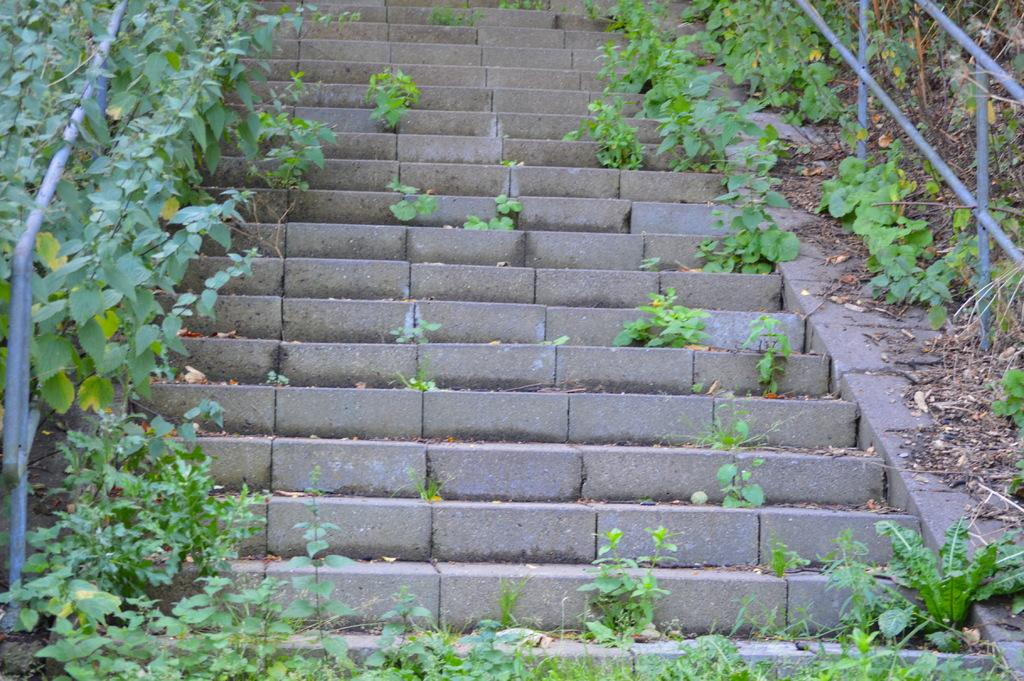What type of architectural feature can be seen in the image? There are steps in the image. What is the purpose of the fencing in the image? The purpose of the fencing in the image is not explicitly stated, but it could be for safety or to mark boundaries. What type of vegetation is present in the image? There is grass in the image. What type of cloud can be seen in the image? There are no clouds present in the image; it only features steps, fencing, and grass. How does the butter contribute to the image? There is no butter present in the image, so it does not contribute to the image. 